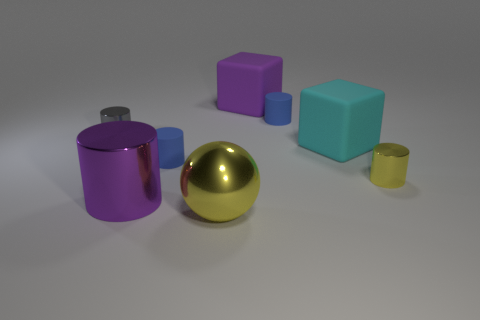How many other things are there of the same size as the cyan thing?
Your answer should be very brief. 3. There is a large matte thing that is the same color as the large metallic cylinder; what is its shape?
Your answer should be very brief. Cube. How many things are either big cubes right of the large purple cylinder or big green rubber cylinders?
Offer a very short reply. 2. What is the size of the purple object that is made of the same material as the large sphere?
Provide a short and direct response. Large. Is the size of the yellow metal ball the same as the purple cube behind the small gray cylinder?
Give a very brief answer. Yes. There is a shiny cylinder that is in front of the cyan cube and behind the large purple shiny thing; what is its color?
Your response must be concise. Yellow. How many things are big spheres that are in front of the small yellow metal cylinder or tiny blue rubber cylinders behind the large yellow metal object?
Make the answer very short. 3. There is a tiny metal cylinder that is right of the large purple object to the left of the big purple object that is behind the small yellow shiny object; what color is it?
Your answer should be compact. Yellow. Are there any tiny blue matte objects of the same shape as the large yellow metal object?
Offer a very short reply. No. What number of blue matte cylinders are there?
Give a very brief answer. 2. 